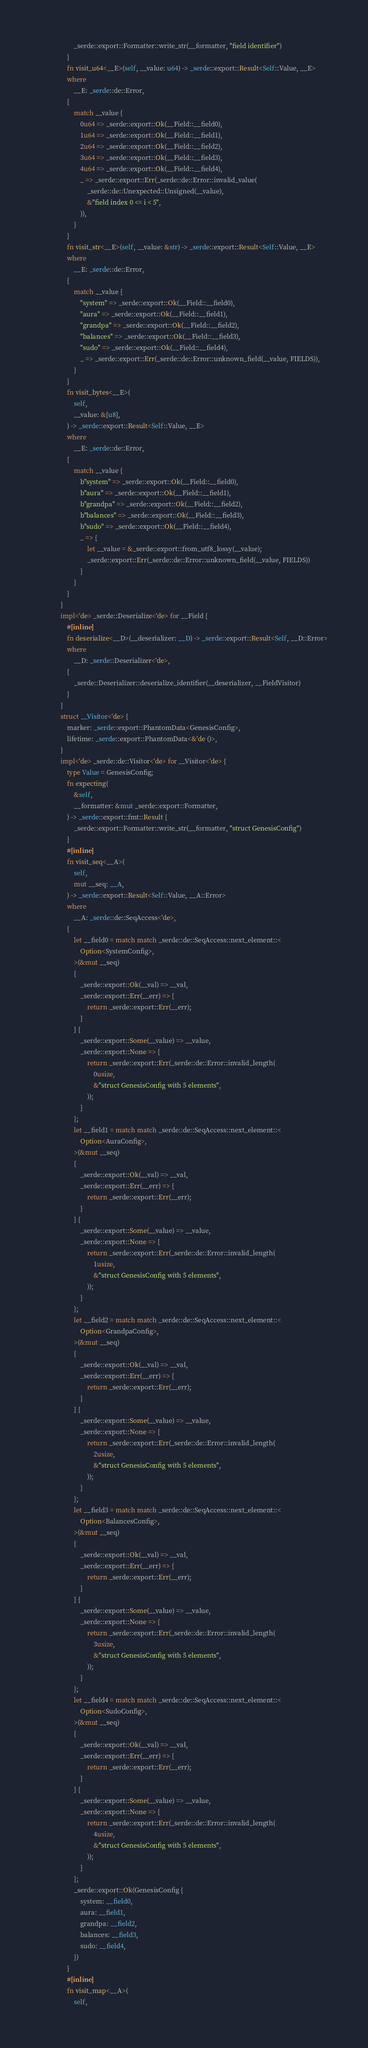Convert code to text. <code><loc_0><loc_0><loc_500><loc_500><_Rust_>					_serde::export::Formatter::write_str(__formatter, "field identifier")
				}
				fn visit_u64<__E>(self, __value: u64) -> _serde::export::Result<Self::Value, __E>
				where
					__E: _serde::de::Error,
				{
					match __value {
						0u64 => _serde::export::Ok(__Field::__field0),
						1u64 => _serde::export::Ok(__Field::__field1),
						2u64 => _serde::export::Ok(__Field::__field2),
						3u64 => _serde::export::Ok(__Field::__field3),
						4u64 => _serde::export::Ok(__Field::__field4),
						_ => _serde::export::Err(_serde::de::Error::invalid_value(
							_serde::de::Unexpected::Unsigned(__value),
							&"field index 0 <= i < 5",
						)),
					}
				}
				fn visit_str<__E>(self, __value: &str) -> _serde::export::Result<Self::Value, __E>
				where
					__E: _serde::de::Error,
				{
					match __value {
						"system" => _serde::export::Ok(__Field::__field0),
						"aura" => _serde::export::Ok(__Field::__field1),
						"grandpa" => _serde::export::Ok(__Field::__field2),
						"balances" => _serde::export::Ok(__Field::__field3),
						"sudo" => _serde::export::Ok(__Field::__field4),
						_ => _serde::export::Err(_serde::de::Error::unknown_field(__value, FIELDS)),
					}
				}
				fn visit_bytes<__E>(
					self,
					__value: &[u8],
				) -> _serde::export::Result<Self::Value, __E>
				where
					__E: _serde::de::Error,
				{
					match __value {
						b"system" => _serde::export::Ok(__Field::__field0),
						b"aura" => _serde::export::Ok(__Field::__field1),
						b"grandpa" => _serde::export::Ok(__Field::__field2),
						b"balances" => _serde::export::Ok(__Field::__field3),
						b"sudo" => _serde::export::Ok(__Field::__field4),
						_ => {
							let __value = &_serde::export::from_utf8_lossy(__value);
							_serde::export::Err(_serde::de::Error::unknown_field(__value, FIELDS))
						}
					}
				}
			}
			impl<'de> _serde::Deserialize<'de> for __Field {
				#[inline]
				fn deserialize<__D>(__deserializer: __D) -> _serde::export::Result<Self, __D::Error>
				where
					__D: _serde::Deserializer<'de>,
				{
					_serde::Deserializer::deserialize_identifier(__deserializer, __FieldVisitor)
				}
			}
			struct __Visitor<'de> {
				marker: _serde::export::PhantomData<GenesisConfig>,
				lifetime: _serde::export::PhantomData<&'de ()>,
			}
			impl<'de> _serde::de::Visitor<'de> for __Visitor<'de> {
				type Value = GenesisConfig;
				fn expecting(
					&self,
					__formatter: &mut _serde::export::Formatter,
				) -> _serde::export::fmt::Result {
					_serde::export::Formatter::write_str(__formatter, "struct GenesisConfig")
				}
				#[inline]
				fn visit_seq<__A>(
					self,
					mut __seq: __A,
				) -> _serde::export::Result<Self::Value, __A::Error>
				where
					__A: _serde::de::SeqAccess<'de>,
				{
					let __field0 = match match _serde::de::SeqAccess::next_element::<
						Option<SystemConfig>,
					>(&mut __seq)
					{
						_serde::export::Ok(__val) => __val,
						_serde::export::Err(__err) => {
							return _serde::export::Err(__err);
						}
					} {
						_serde::export::Some(__value) => __value,
						_serde::export::None => {
							return _serde::export::Err(_serde::de::Error::invalid_length(
								0usize,
								&"struct GenesisConfig with 5 elements",
							));
						}
					};
					let __field1 = match match _serde::de::SeqAccess::next_element::<
						Option<AuraConfig>,
					>(&mut __seq)
					{
						_serde::export::Ok(__val) => __val,
						_serde::export::Err(__err) => {
							return _serde::export::Err(__err);
						}
					} {
						_serde::export::Some(__value) => __value,
						_serde::export::None => {
							return _serde::export::Err(_serde::de::Error::invalid_length(
								1usize,
								&"struct GenesisConfig with 5 elements",
							));
						}
					};
					let __field2 = match match _serde::de::SeqAccess::next_element::<
						Option<GrandpaConfig>,
					>(&mut __seq)
					{
						_serde::export::Ok(__val) => __val,
						_serde::export::Err(__err) => {
							return _serde::export::Err(__err);
						}
					} {
						_serde::export::Some(__value) => __value,
						_serde::export::None => {
							return _serde::export::Err(_serde::de::Error::invalid_length(
								2usize,
								&"struct GenesisConfig with 5 elements",
							));
						}
					};
					let __field3 = match match _serde::de::SeqAccess::next_element::<
						Option<BalancesConfig>,
					>(&mut __seq)
					{
						_serde::export::Ok(__val) => __val,
						_serde::export::Err(__err) => {
							return _serde::export::Err(__err);
						}
					} {
						_serde::export::Some(__value) => __value,
						_serde::export::None => {
							return _serde::export::Err(_serde::de::Error::invalid_length(
								3usize,
								&"struct GenesisConfig with 5 elements",
							));
						}
					};
					let __field4 = match match _serde::de::SeqAccess::next_element::<
						Option<SudoConfig>,
					>(&mut __seq)
					{
						_serde::export::Ok(__val) => __val,
						_serde::export::Err(__err) => {
							return _serde::export::Err(__err);
						}
					} {
						_serde::export::Some(__value) => __value,
						_serde::export::None => {
							return _serde::export::Err(_serde::de::Error::invalid_length(
								4usize,
								&"struct GenesisConfig with 5 elements",
							));
						}
					};
					_serde::export::Ok(GenesisConfig {
						system: __field0,
						aura: __field1,
						grandpa: __field2,
						balances: __field3,
						sudo: __field4,
					})
				}
				#[inline]
				fn visit_map<__A>(
					self,</code> 